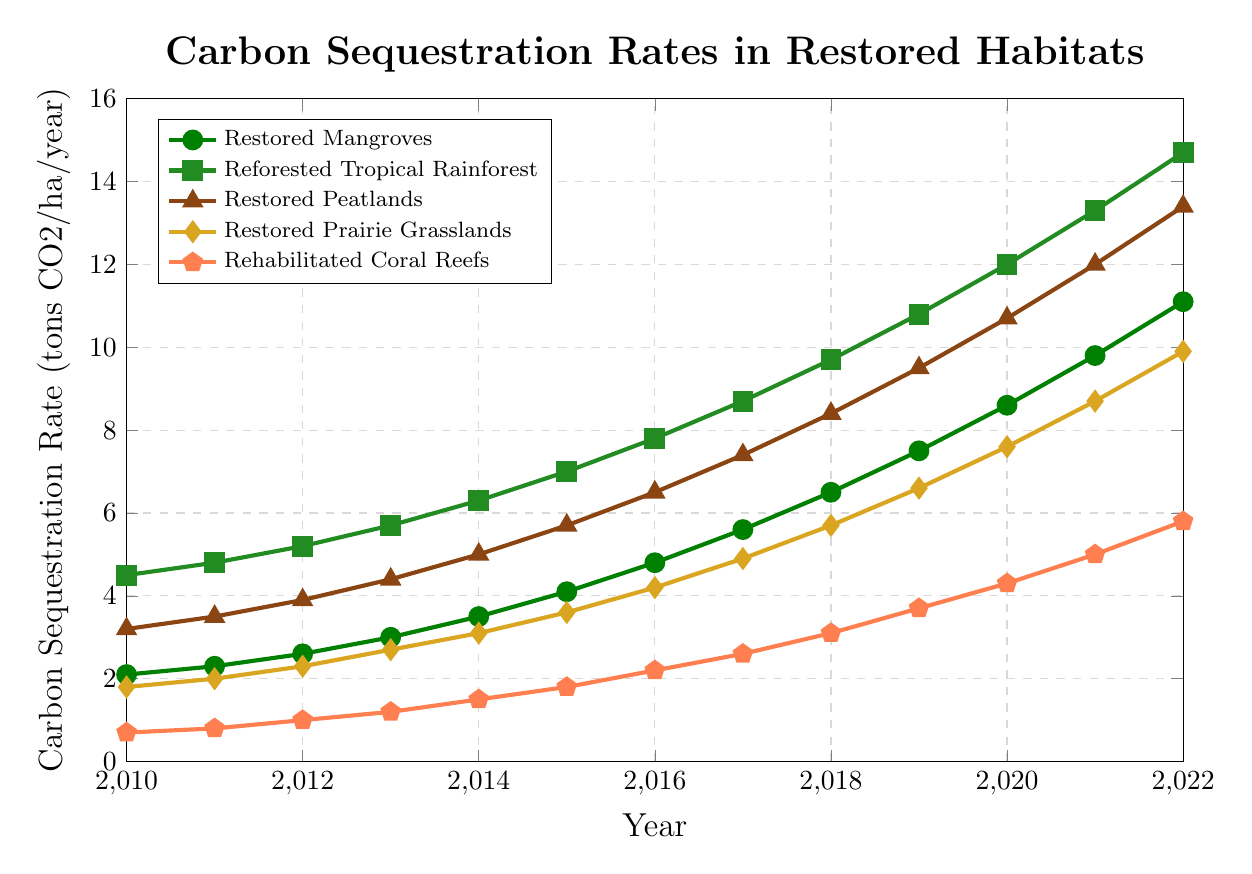What was the carbon sequestration rate for Restored Mangroves in 2015? Locate the Restored Mangroves data series (green with circular markers) and find the value for 2015. The rate is at 4.1 tons CO2/ha/year.
Answer: 4.1 In which year did Rehabilitated Coral Reefs surpass 3 tons CO2/ha/year? Look at the Rehabilitated Coral Reefs data series (orange with pentagon markers) and identify the year where the rate exceeds 3 tons CO2/ha/year for the first time, which is in 2018.
Answer: 2018 Which habitat had the highest carbon sequestration rate in 2022? Compare the values in 2022 for all habitats. Reforested Tropical Rainforest has the highest value at 14.7 tons CO2/ha/year.
Answer: Reforested Tropical Rainforest By how much did the carbon sequestration rate increase for Restored Peatlands from 2010 to 2022? Subtract the 2010 value from the 2022 value for Restored Peatlands. This is 13.4 - 3.2 = 10.2 tons CO2/ha/year.
Answer: 10.2 What is the carbon sequestration trend for Restored Prairie Grasslands between 2015 and 2020? Observe the values for Restored Prairie Grasslands from 2015 to 2020. The values show a consistent increase from 3.6 to 7.6 tons CO2/ha/year.
Answer: Increasing How does the carbon sequestration rate of Restored Mangroves in 2020 compare to that of Rehabilitated Coral Reefs in 2022? Compare the carbon sequestration rate of Restored Mangroves in 2020 (8.6 tons CO2/ha/year) to Rehabilitated Coral Reefs in 2022 (5.8 tons CO2/ha/year). Restored Mangroves have a higher rate in 2020.
Answer: Higher On average, how much did the carbon sequestration rate of Reforested Tropical Rainforest increase each year from 2010 to 2022? Calculate the total increase from 2010 to 2022 (14.7 - 4.5 = 10.2 tons CO2/ha/year) and divide by the number of years (2022 - 2010 = 12 years). The average annual increase is 10.2 / 12 ≈ 0.85 tons CO2/ha/year.
Answer: ≈ 0.85 How many habitats have carbon sequestration rates greater than 10 tons CO2/ha/year in 2022? Identify the habitats with rates exceeding 10 tons CO2/ha/year in 2022. They are Reforested Tropical Rainforest, Restored Peatlands, and Restored Mangroves. Three habitats in total.
Answer: 3 What is the difference in carbon sequestration rates between Restored Mangroves and Restored Prairie Grasslands in 2022? Subtract the 2022 rate of Restored Prairie Grasslands (9.9 tons CO2/ha/year) from that of Restored Mangroves (11.1 tons CO2/ha/year), which is 11.1 - 9.9 = 1.2 tons CO2/ha/year.
Answer: 1.2 